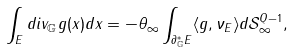<formula> <loc_0><loc_0><loc_500><loc_500>\int _ { E } d i v _ { \mathbb { G } } g ( x ) d x = - \theta _ { \infty } \int _ { \partial _ { \mathbb { G } } ^ { \ast } E } \langle g , \nu _ { E } \rangle d { \mathcal { S } } _ { \infty } ^ { Q - 1 } ,</formula> 